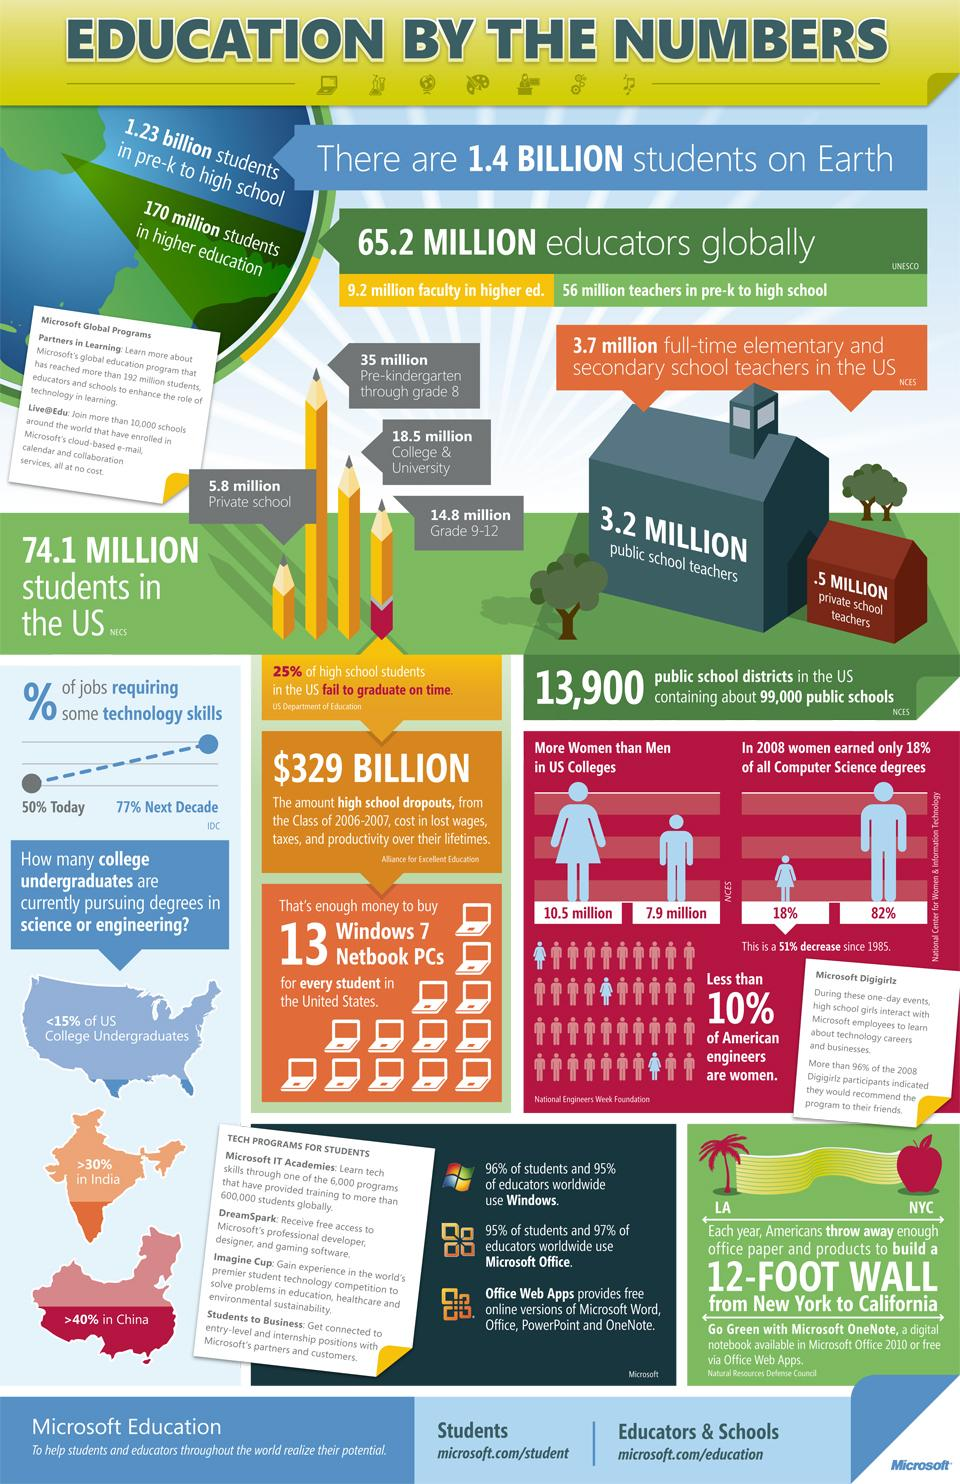Give some essential details in this illustration. In 2008, the population of women attending colleges in the United States was approximately 10.5 million. In 2008, the population of men attending colleges in the United States was estimated to be approximately 7.9 million. According to recent data, over 30% of college undergraduates in India are currently pursuing degrees in science or engineering. In 2008, 82% of all computer science degrees earned in the United States were awarded to men. 